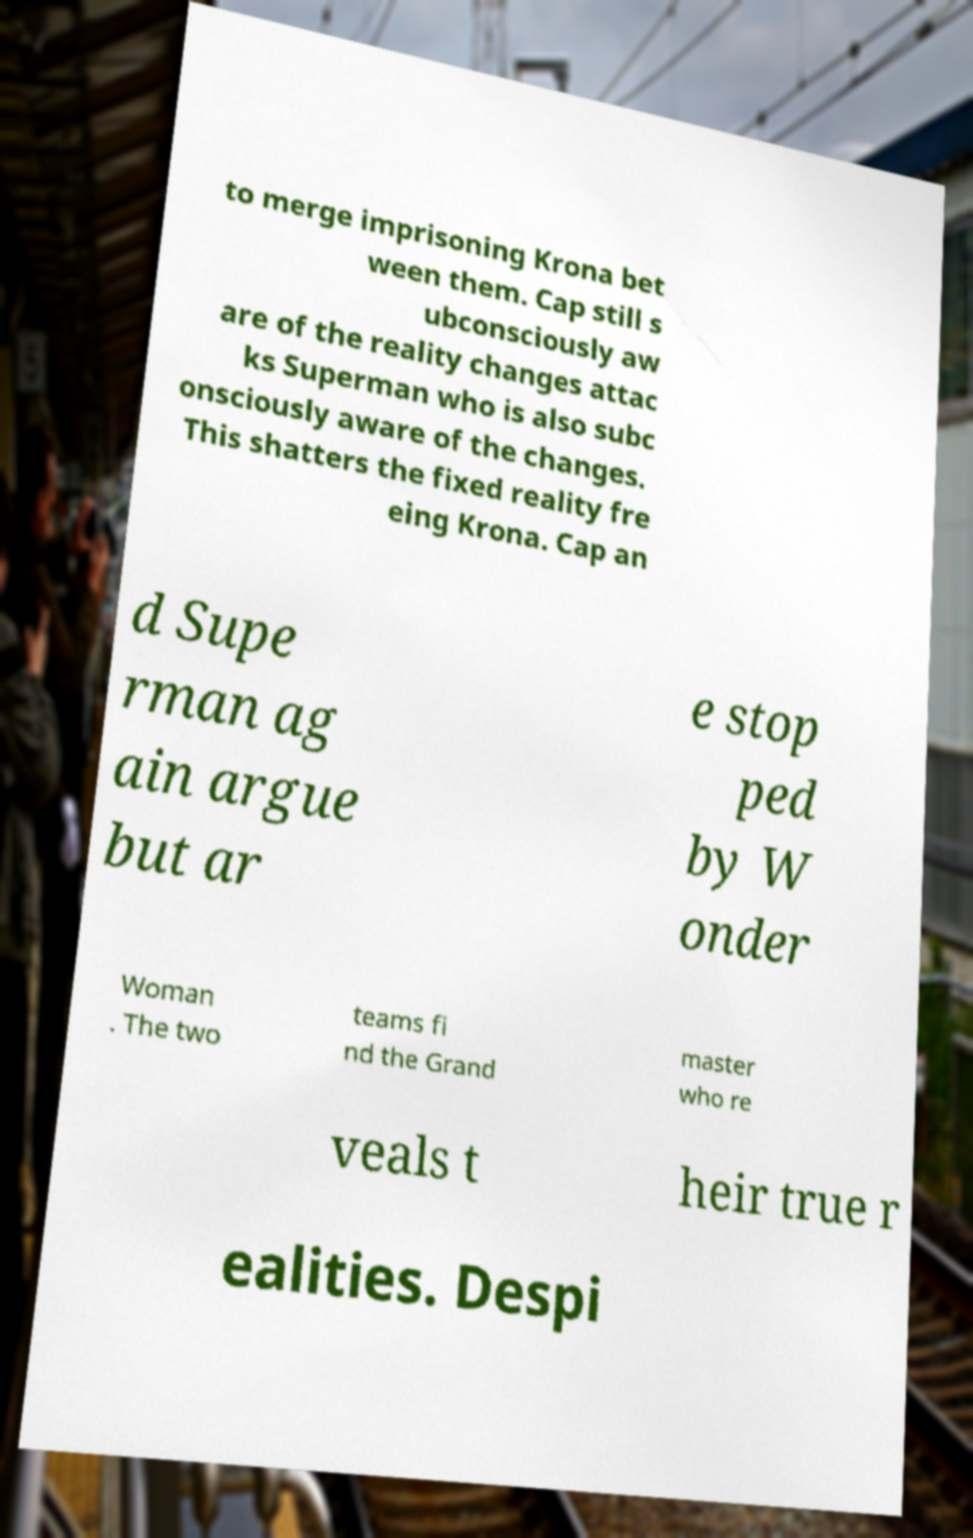Can you accurately transcribe the text from the provided image for me? to merge imprisoning Krona bet ween them. Cap still s ubconsciously aw are of the reality changes attac ks Superman who is also subc onsciously aware of the changes. This shatters the fixed reality fre eing Krona. Cap an d Supe rman ag ain argue but ar e stop ped by W onder Woman . The two teams fi nd the Grand master who re veals t heir true r ealities. Despi 